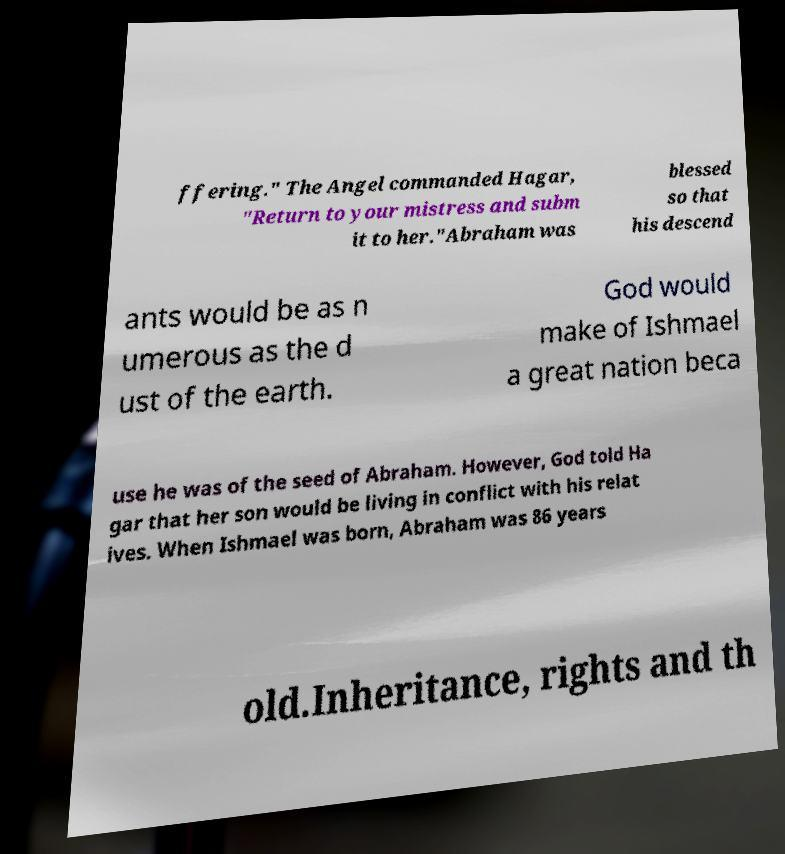I need the written content from this picture converted into text. Can you do that? ffering." The Angel commanded Hagar, "Return to your mistress and subm it to her."Abraham was blessed so that his descend ants would be as n umerous as the d ust of the earth. God would make of Ishmael a great nation beca use he was of the seed of Abraham. However, God told Ha gar that her son would be living in conflict with his relat ives. When Ishmael was born, Abraham was 86 years old.Inheritance, rights and th 